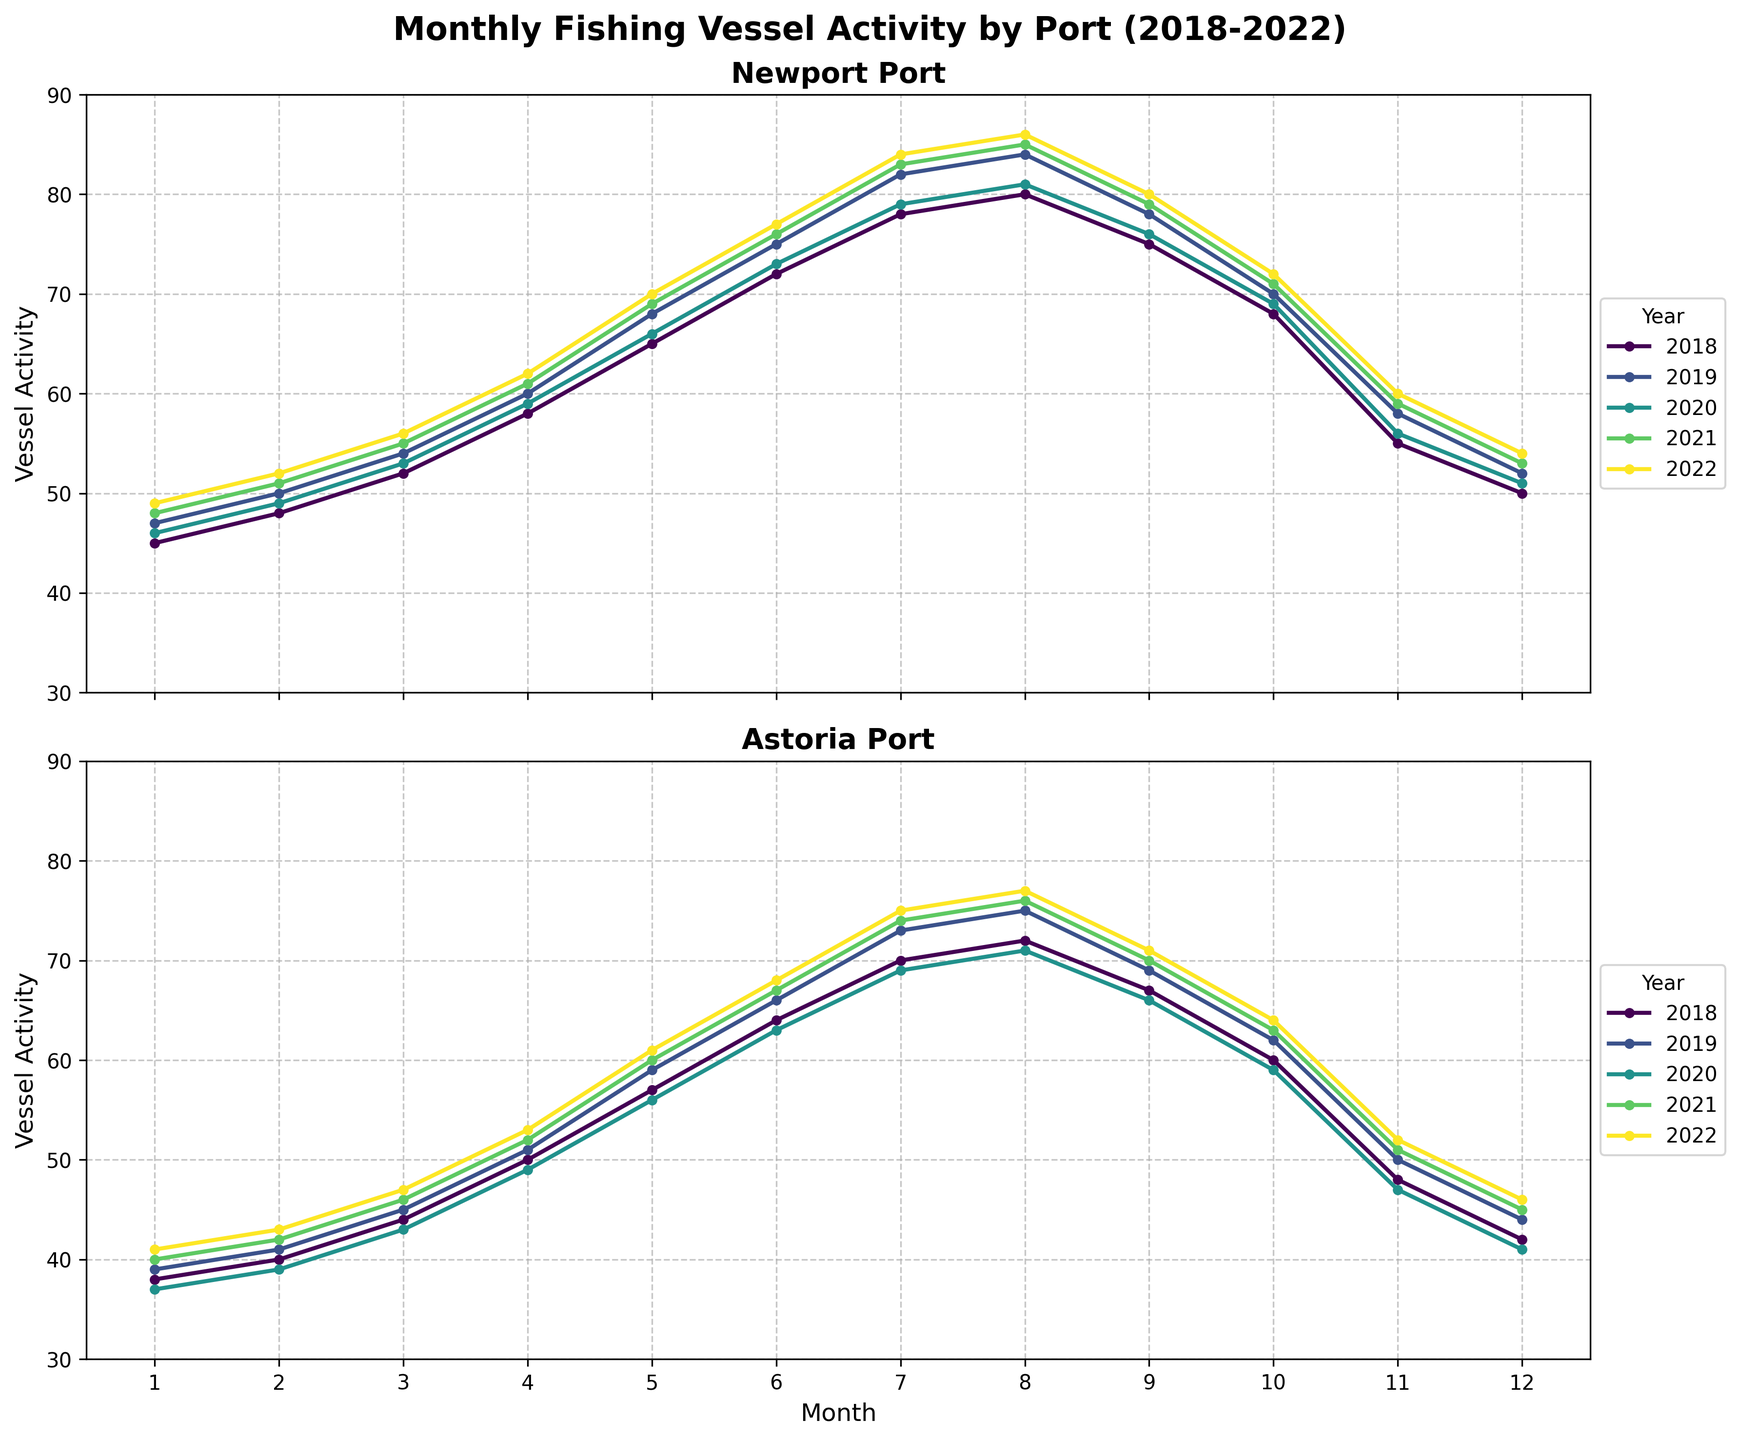What is the general trend of vessel activity in Newport Port over the years? By observing the line trends and color-coded lines over the years, we notice the vessel activity steadily increases from January to August and then decreases until December. Each year follows a similar pattern, with activity peaking in the summer months.
Answer: Increasing until August, then decreasing Which month has the highest vessel activity in Astoria Port in 2022? To determine the highest activity, look for the peak of the 2022 (colored) line within the Astoria subplot. The highest point is in August.
Answer: August Compare the vessel activities of Newport Port and Astoria Port in July 2019. Which port had more activity? Compare the values for July 2019 in each subplot: Newport Port shows an activity of 82, while Astoria Port shows 73.
Answer: Newport Port What is the difference in vessel activity between June and December 2021 in Astoria Port? In Astoria Port's subplot, the 2021 line shows vessel activity at 67 in June and 45 in December. The difference is calculated as 67 - 45.
Answer: 22 What is the average vessel activity in Newport Port in 2020? Sum all monthly activity values for Newport in 2020 (46+49+53+59+66+73+79+81+76+69+56+51) = 758, then divide by 12 months: 758 / 12.
Answer: 63.17 How does the vessel activity of Newport Port in May compare across the years 2018–2022? Check the values for May in Newport's subplot for each year: 2018 (65), 2019 (68), 2020 (66), 2021 (69), 2022 (70). They generally increase over the years.
Answer: Gradually increasing Which port experienced a larger drop in vessel activity from October to November 2020? Compare the activity between October and November 2020 in both subplots: Newport (69 to 56) and Astoria (59 to 47). Astoria shows a larger drop (12 units compared to Newport's 13 units).
Answer: Astoria What is the visual color marking for vessel activity trends in 2021? In the subplots, each year is represented by a distinct color. We identify the lines of 2021 colored consistently across both subplots.
Answer: A specific color (e.g., green or blue depending on provided figure) For which year did Newport Port see the highest vessel activity peak in any month, and what was the value? Look for the highest peak in Newport Port's subplot. The highest value is 86 in August 2022.
Answer: 2022, 86 